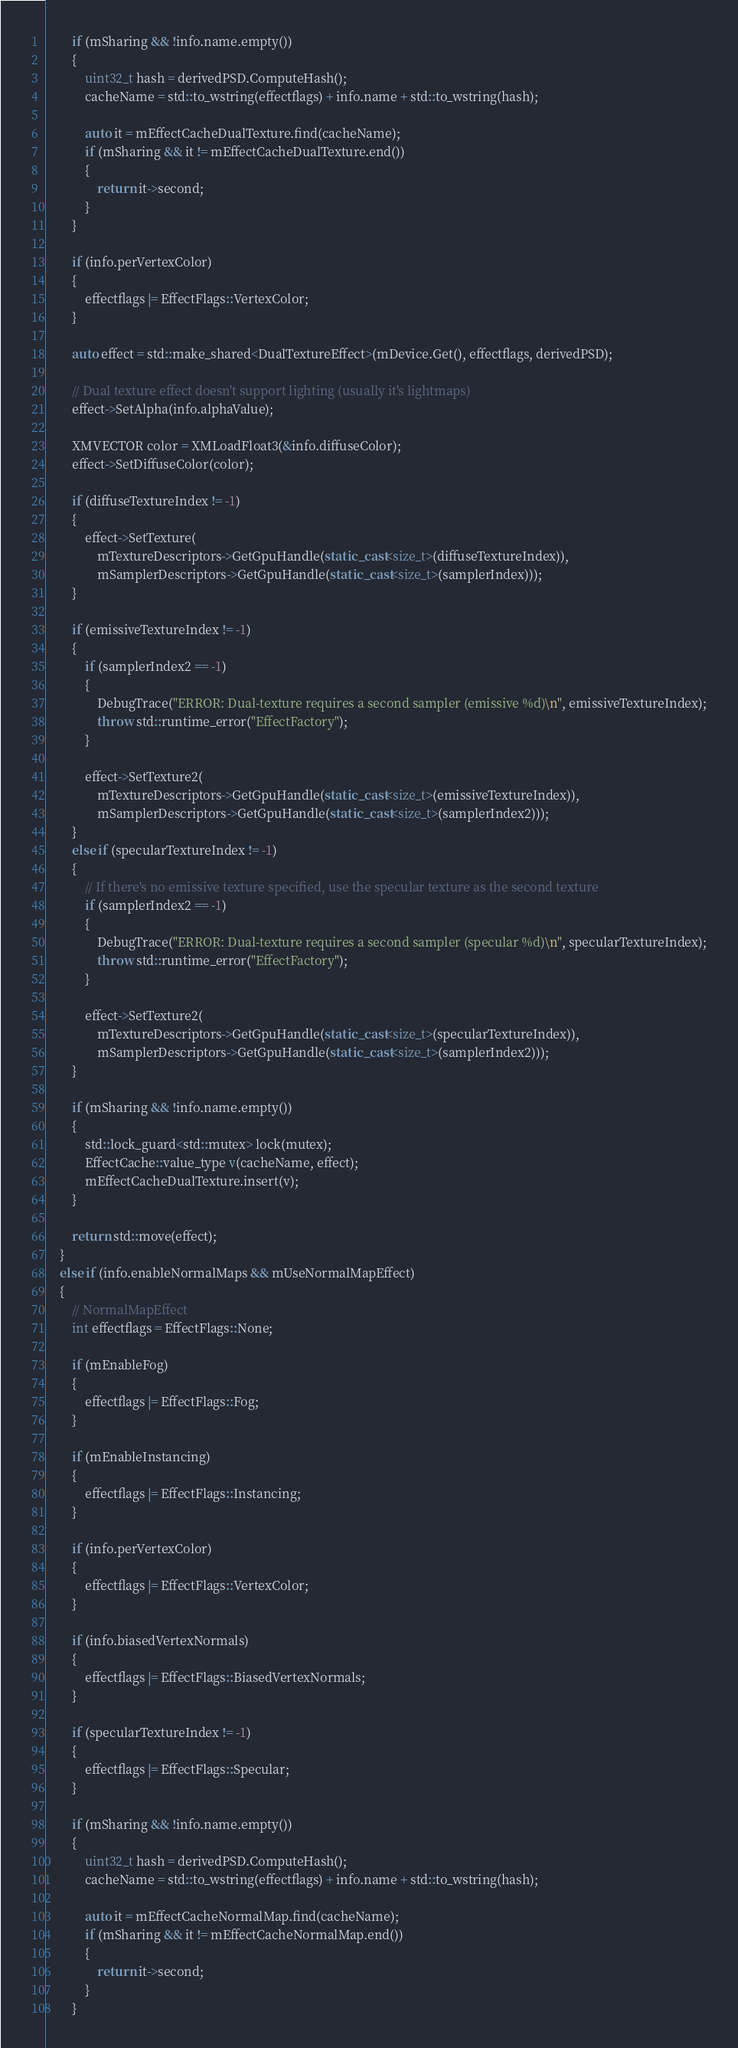<code> <loc_0><loc_0><loc_500><loc_500><_C++_>
        if (mSharing && !info.name.empty())
        {
            uint32_t hash = derivedPSD.ComputeHash();
            cacheName = std::to_wstring(effectflags) + info.name + std::to_wstring(hash);

            auto it = mEffectCacheDualTexture.find(cacheName);
            if (mSharing && it != mEffectCacheDualTexture.end())
            {
                return it->second;
            }
        }

        if (info.perVertexColor)
        {
            effectflags |= EffectFlags::VertexColor;
        }

        auto effect = std::make_shared<DualTextureEffect>(mDevice.Get(), effectflags, derivedPSD);

        // Dual texture effect doesn't support lighting (usually it's lightmaps)
        effect->SetAlpha(info.alphaValue);

        XMVECTOR color = XMLoadFloat3(&info.diffuseColor);
        effect->SetDiffuseColor(color);

        if (diffuseTextureIndex != -1)
        {
            effect->SetTexture(
                mTextureDescriptors->GetGpuHandle(static_cast<size_t>(diffuseTextureIndex)),
                mSamplerDescriptors->GetGpuHandle(static_cast<size_t>(samplerIndex)));
        }

        if (emissiveTextureIndex != -1)
        {
            if (samplerIndex2 == -1)
            {
                DebugTrace("ERROR: Dual-texture requires a second sampler (emissive %d)\n", emissiveTextureIndex);
                throw std::runtime_error("EffectFactory");
            }

            effect->SetTexture2(
                mTextureDescriptors->GetGpuHandle(static_cast<size_t>(emissiveTextureIndex)),
                mSamplerDescriptors->GetGpuHandle(static_cast<size_t>(samplerIndex2)));
        }
        else if (specularTextureIndex != -1)
        {
            // If there's no emissive texture specified, use the specular texture as the second texture
            if (samplerIndex2 == -1)
            {
                DebugTrace("ERROR: Dual-texture requires a second sampler (specular %d)\n", specularTextureIndex);
                throw std::runtime_error("EffectFactory");
            }

            effect->SetTexture2(
                mTextureDescriptors->GetGpuHandle(static_cast<size_t>(specularTextureIndex)),
                mSamplerDescriptors->GetGpuHandle(static_cast<size_t>(samplerIndex2)));
        }

        if (mSharing && !info.name.empty())
        {
            std::lock_guard<std::mutex> lock(mutex);
            EffectCache::value_type v(cacheName, effect);
            mEffectCacheDualTexture.insert(v);
        }

        return std::move(effect);
    }
    else if (info.enableNormalMaps && mUseNormalMapEffect)
    {
        // NormalMapEffect
        int effectflags = EffectFlags::None;

        if (mEnableFog)
        {
            effectflags |= EffectFlags::Fog;
        }

        if (mEnableInstancing)
        {
            effectflags |= EffectFlags::Instancing;
        }

        if (info.perVertexColor)
        {
            effectflags |= EffectFlags::VertexColor;
        }

        if (info.biasedVertexNormals)
        {
            effectflags |= EffectFlags::BiasedVertexNormals;
        }

        if (specularTextureIndex != -1)
        {
            effectflags |= EffectFlags::Specular;
        }

        if (mSharing && !info.name.empty())
        {
            uint32_t hash = derivedPSD.ComputeHash();
            cacheName = std::to_wstring(effectflags) + info.name + std::to_wstring(hash);

            auto it = mEffectCacheNormalMap.find(cacheName);
            if (mSharing && it != mEffectCacheNormalMap.end())
            {
                return it->second;
            }
        }
</code> 